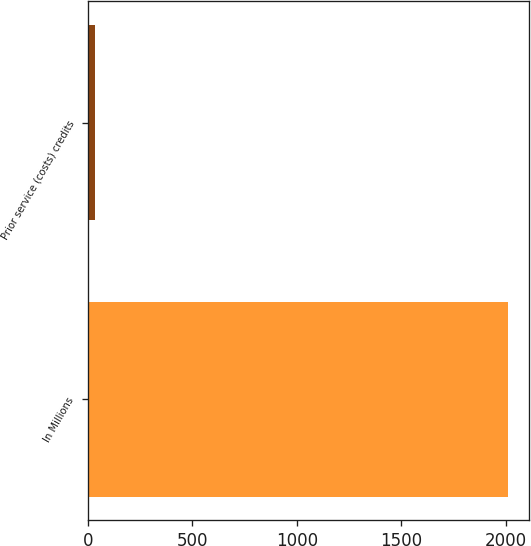Convert chart. <chart><loc_0><loc_0><loc_500><loc_500><bar_chart><fcel>In Millions<fcel>Prior service (costs) credits<nl><fcel>2011<fcel>35.8<nl></chart> 